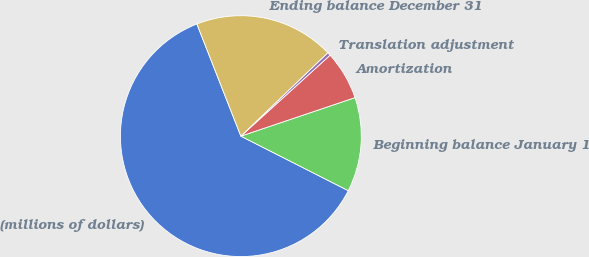Convert chart to OTSL. <chart><loc_0><loc_0><loc_500><loc_500><pie_chart><fcel>(millions of dollars)<fcel>Beginning balance January 1<fcel>Amortization<fcel>Translation adjustment<fcel>Ending balance December 31<nl><fcel>61.57%<fcel>12.66%<fcel>6.55%<fcel>0.44%<fcel>18.78%<nl></chart> 